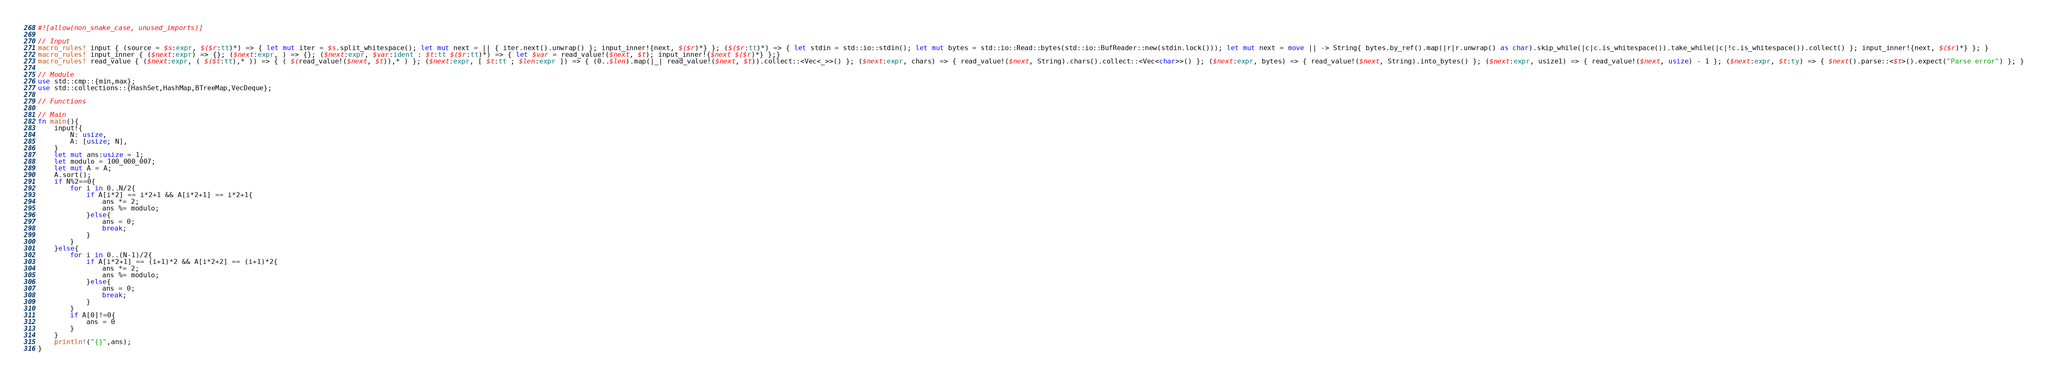<code> <loc_0><loc_0><loc_500><loc_500><_Rust_>#![allow(non_snake_case, unused_imports)]

// Input
macro_rules! input { (source = $s:expr, $($r:tt)*) => { let mut iter = $s.split_whitespace(); let mut next = || { iter.next().unwrap() }; input_inner!{next, $($r)*} }; ($($r:tt)*) => { let stdin = std::io::stdin(); let mut bytes = std::io::Read::bytes(std::io::BufReader::new(stdin.lock())); let mut next = move || -> String{ bytes.by_ref().map(|r|r.unwrap() as char).skip_while(|c|c.is_whitespace()).take_while(|c|!c.is_whitespace()).collect() }; input_inner!{next, $($r)*} }; }
macro_rules! input_inner { ($next:expr) => {}; ($next:expr, ) => {}; ($next:expr, $var:ident : $t:tt $($r:tt)*) => { let $var = read_value!($next, $t); input_inner!{$next $($r)*} };}
macro_rules! read_value { ($next:expr, ( $($t:tt),* )) => { ( $(read_value!($next, $t)),* ) }; ($next:expr, [ $t:tt ; $len:expr ]) => { (0..$len).map(|_| read_value!($next, $t)).collect::<Vec<_>>() }; ($next:expr, chars) => { read_value!($next, String).chars().collect::<Vec<char>>() }; ($next:expr, bytes) => { read_value!($next, String).into_bytes() }; ($next:expr, usize1) => { read_value!($next, usize) - 1 }; ($next:expr, $t:ty) => { $next().parse::<$t>().expect("Parse error") }; }

// Module
use std::cmp::{min,max};
use std::collections::{HashSet,HashMap,BTreeMap,VecDeque};

// Functions

// Main
fn main(){
    input!{
        N: usize,
        A: [usize; N],
    }
    let mut ans:usize = 1;
    let modulo = 100_000_007;
    let mut A = A;
    A.sort();
    if N%2==0{
        for i in 0..N/2{
            if A[i*2] == i*2+1 && A[i*2+1] == i*2+1{
                ans *= 2;
                ans %= modulo;
            }else{
                ans = 0;
                break;
            }
        }
    }else{
        for i in 0..(N-1)/2{
            if A[i*2+1] == (i+1)*2 && A[i*2+2] == (i+1)*2{
                ans *= 2;
                ans %= modulo;
            }else{
                ans = 0;
                break;
            }
        }
        if A[0]!=0{
            ans = 0
        }
    }
    println!("{}",ans);
}</code> 